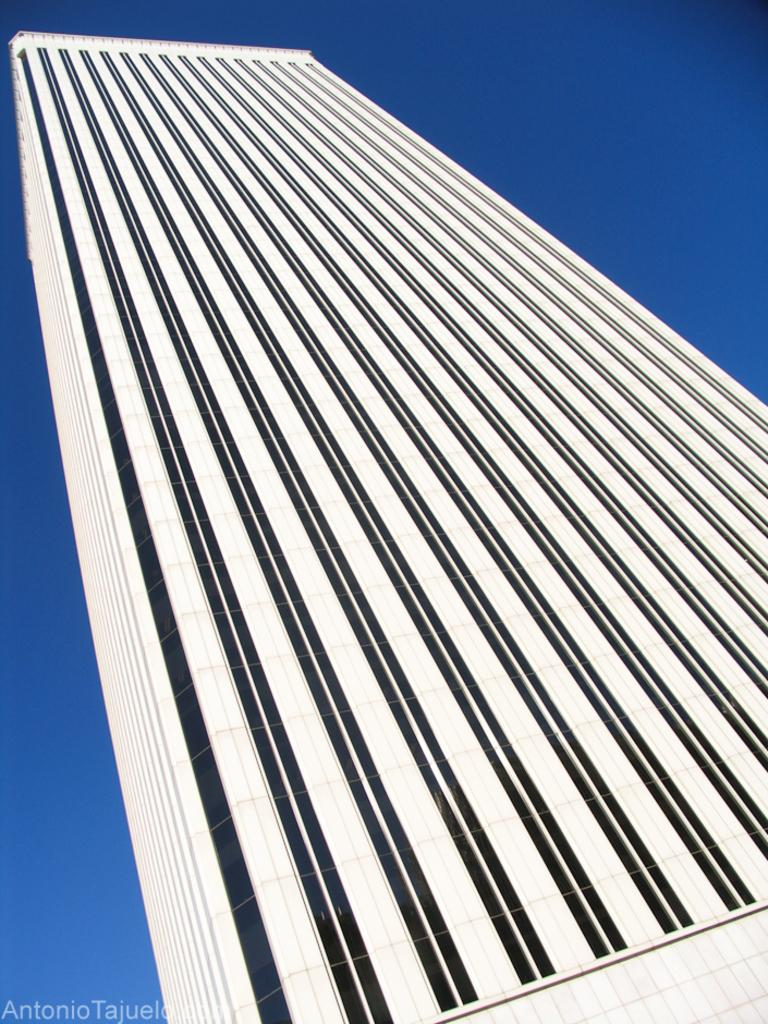What type of structure is visible in the image? There is a building with walls and glasses in the image. What can be seen in the background of the image? The background of the image includes the sky. Is there any additional information or marking present in the image? Yes, there is a watermark at the bottom of the image. Can you see any matches being lit in the image? There are no matches present in the image. Is there a sink visible in the image? There is no sink visible in the image. 